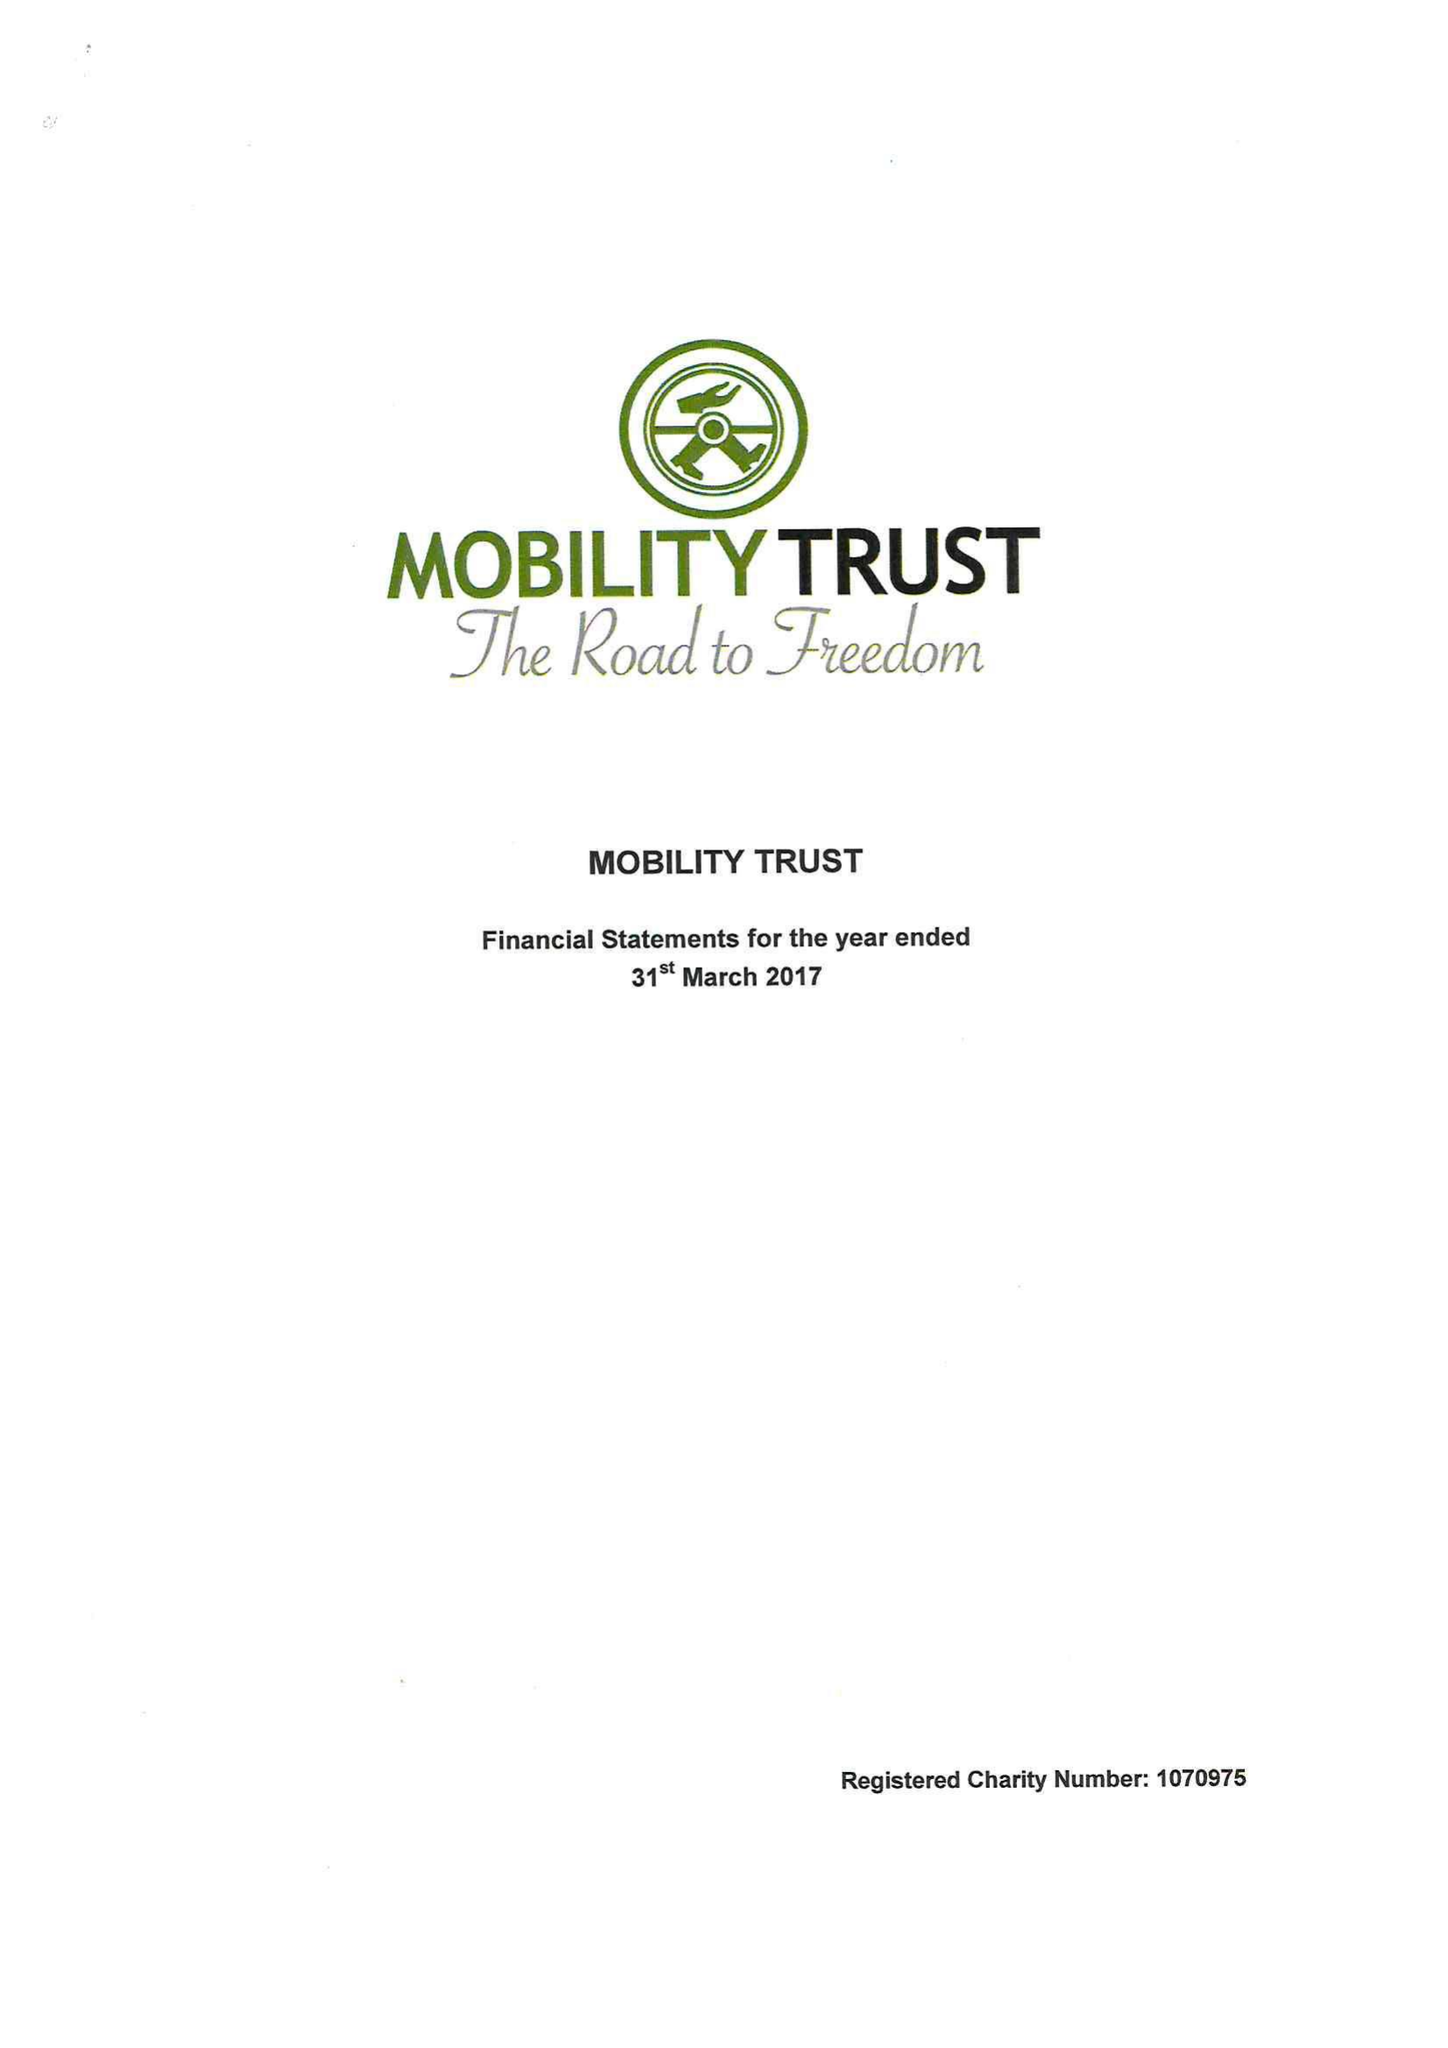What is the value for the address__postcode?
Answer the question using a single word or phrase. RG8 7LR 